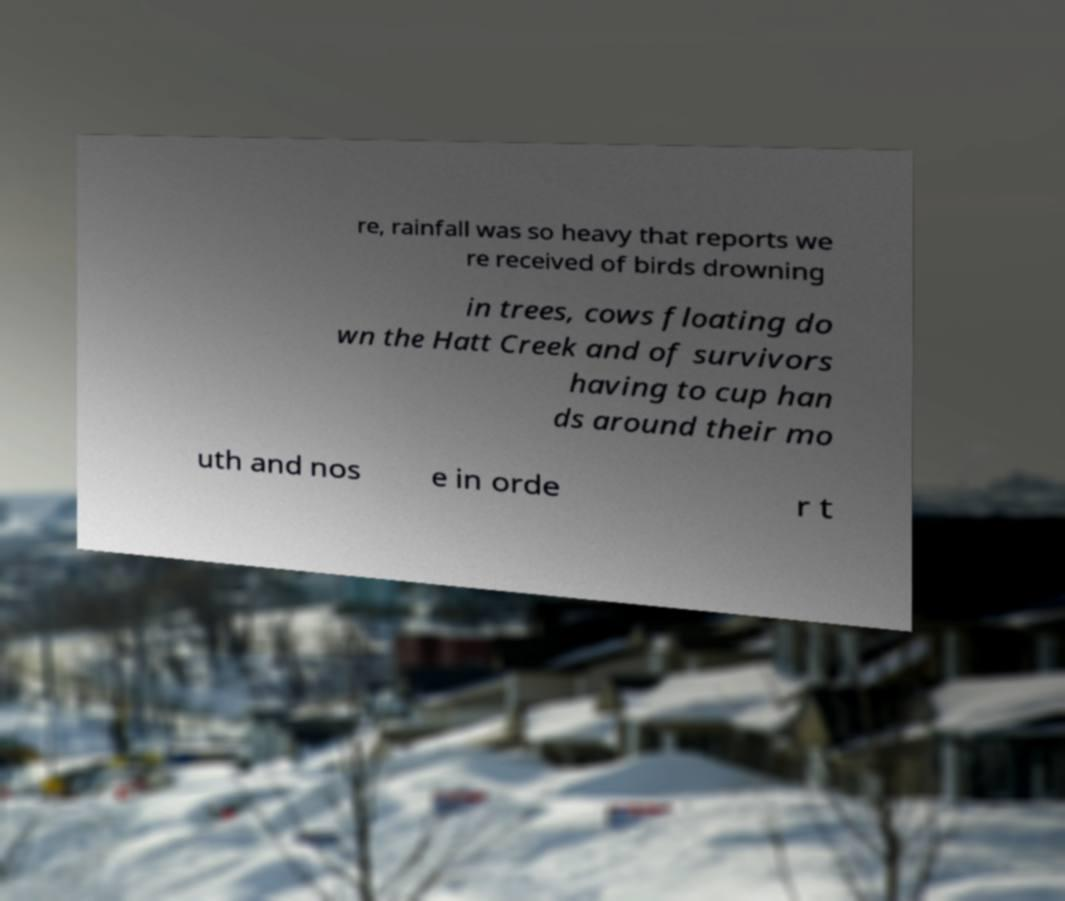Could you extract and type out the text from this image? re, rainfall was so heavy that reports we re received of birds drowning in trees, cows floating do wn the Hatt Creek and of survivors having to cup han ds around their mo uth and nos e in orde r t 